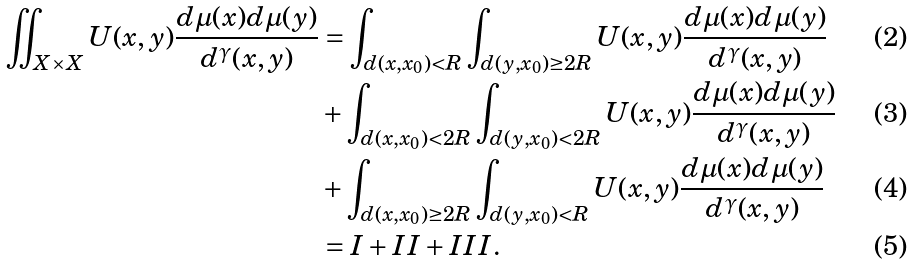<formula> <loc_0><loc_0><loc_500><loc_500>\iint _ { X \times X } U ( x , y ) \frac { d \mu ( x ) d \mu ( y ) } { d ^ { \gamma } ( x , y ) } & = \int _ { d ( x , x _ { 0 } ) < R } \int _ { d ( y , x _ { 0 } ) \geq 2 R } U ( x , y ) \frac { d \mu ( x ) d \mu ( y ) } { d ^ { \gamma } ( x , y ) } \\ & + \int _ { d ( x , x _ { 0 } ) < 2 R } \int _ { d ( y , x _ { 0 } ) < 2 R } U ( x , y ) \frac { d \mu ( x ) d \mu ( y ) } { d ^ { \gamma } ( x , y ) } \\ & + \int _ { d ( x , x _ { 0 } ) \geq 2 R } \int _ { d ( y , x _ { 0 } ) < R } U ( x , y ) \frac { d \mu ( x ) d \mu ( y ) } { d ^ { \gamma } ( x , y ) } \\ & = I + I I + I I I .</formula> 